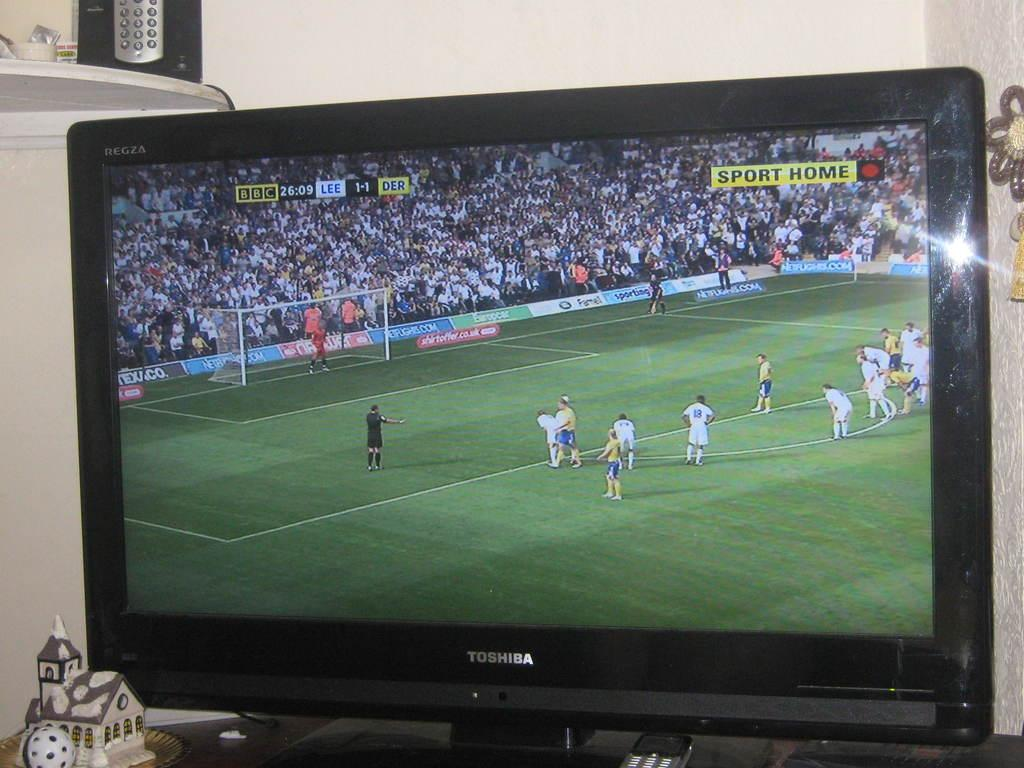<image>
Share a concise interpretation of the image provided. A TV showing a football game with the words Sport Home on the  top right. 